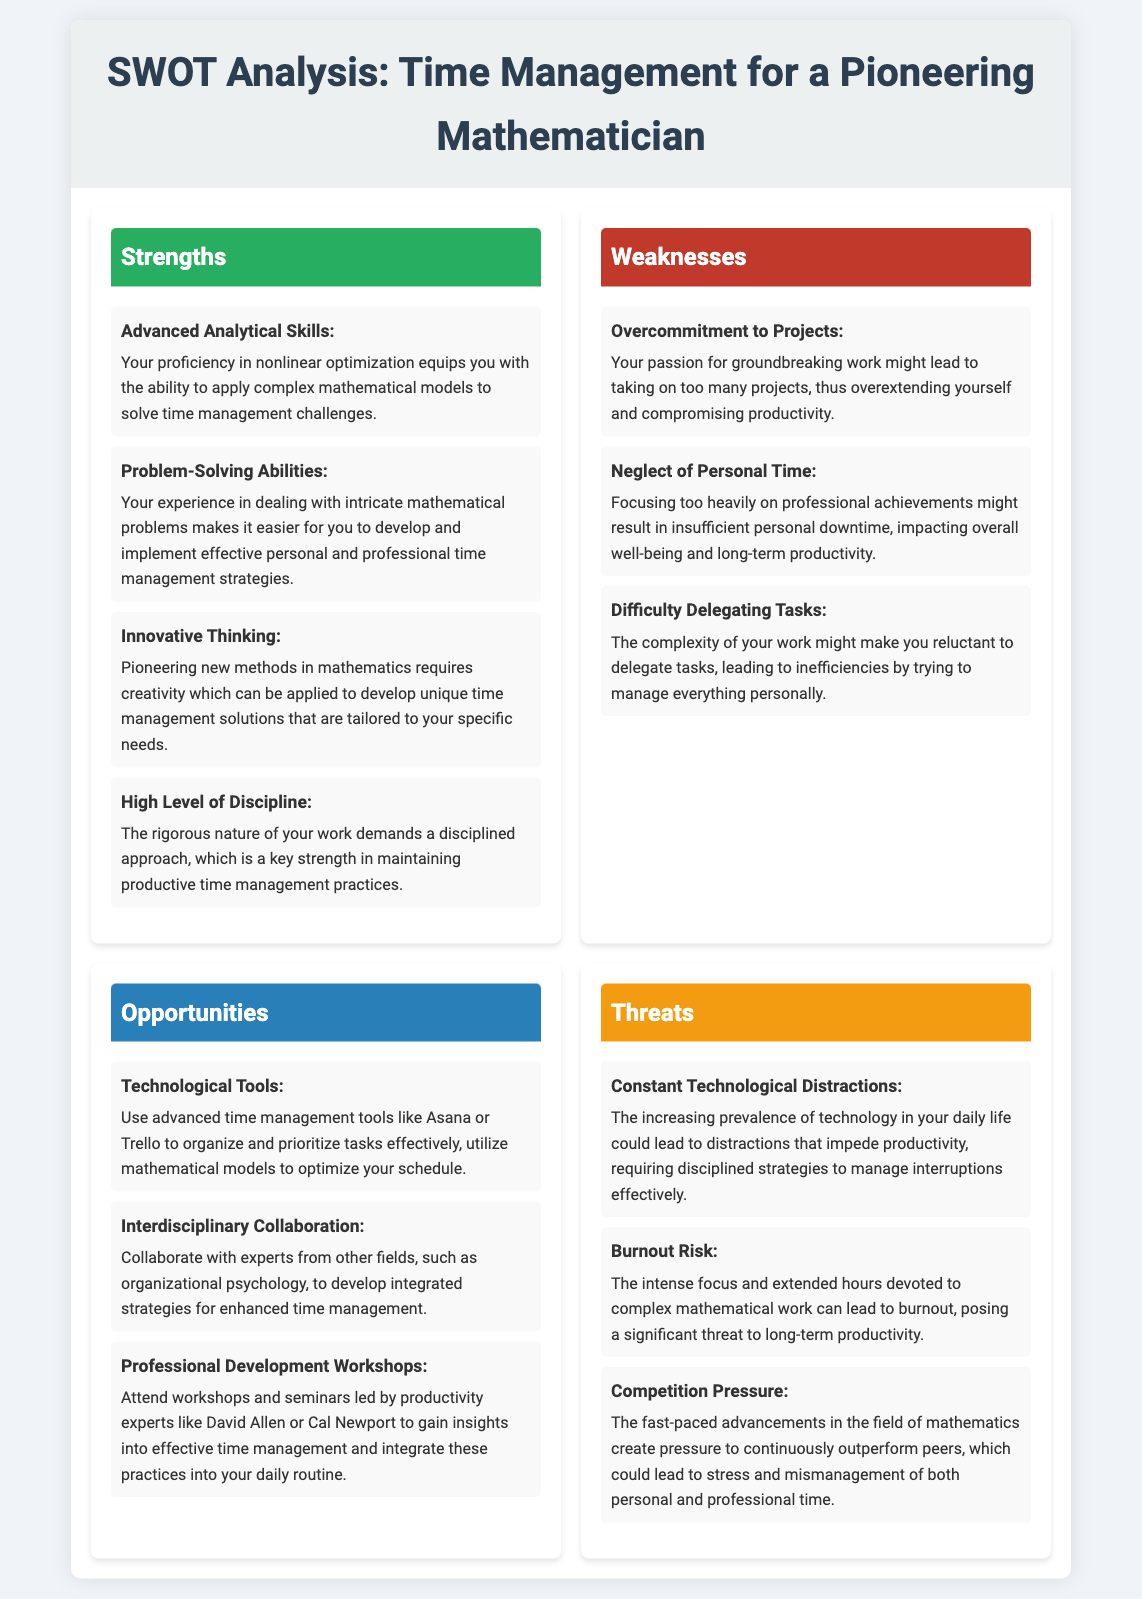what is the title of the document? The title of the document is specified in the `<title>` tag and is prominently displayed at the top.
Answer: SWOT Analysis: Time Management for a Pioneering Mathematician how many strengths are listed? The number of strengths can be counted from the bulleted list in the Strengths section.
Answer: Four what is one of the weaknesses mentioned? The weaknesses section lists specific shortcomings that can be found in the document.
Answer: Overcommitment to Projects who are the productivity experts suggested for workshops? The names of the suggested productivity experts are mentioned in the Opportunities section.
Answer: David Allen or Cal Newport what technology tool is recommended for time management? The document lists advanced technological tools that can assist in time management.
Answer: Asana or Trello which section addresses the risk of burnout? The threat related to burnout can be identified in the Threats section of the document.
Answer: Threats how many opportunities are identified? The number of unique opportunities is stated in the Opportunities section and can be counted.
Answer: Three what threat is associated with technological distractions? The document highlights specific threats, including one linked to technology.
Answer: Constant Technological Distractions what is a listed strength related to discipline? One of the strengths pertains to maintaining productive time management practices.
Answer: High Level of Discipline 